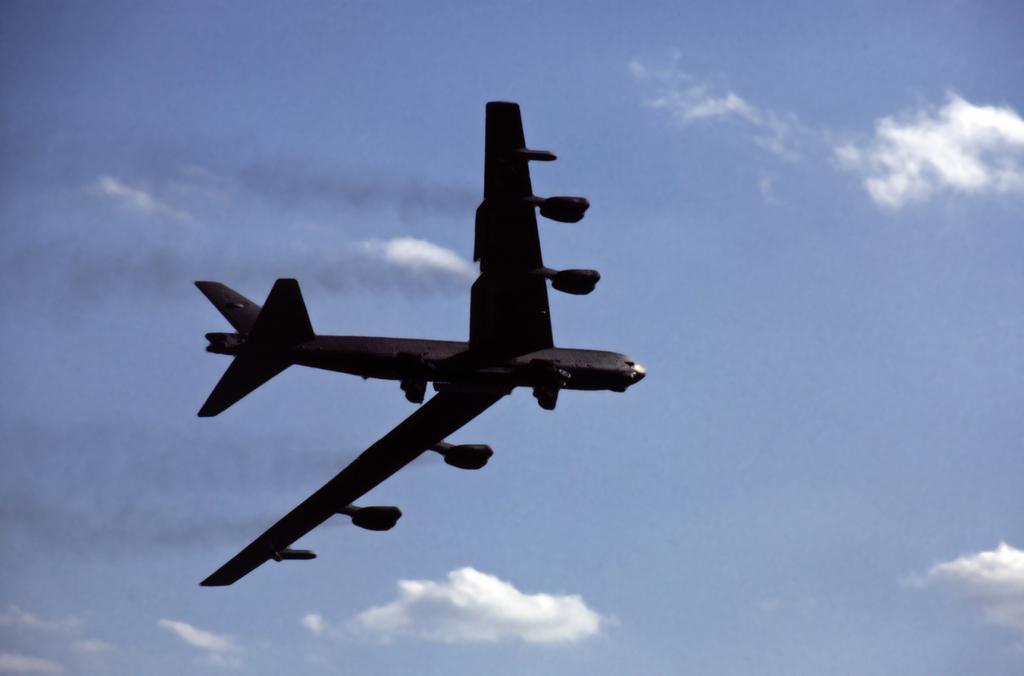Please provide a concise description of this image. There is an aeroplane in the sky. There are some cloud patches on the sky. 